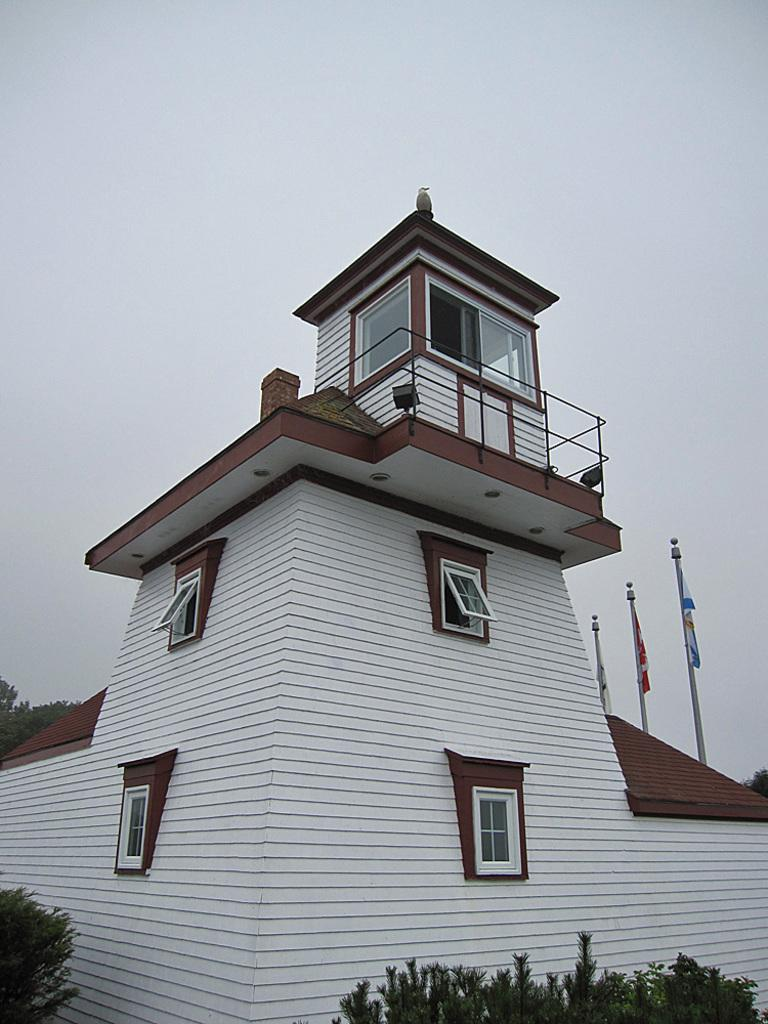What type of structure is present in the image? There is a building in the image. What features can be observed on the building? The building has windows and railings. What is located at the bottom of the image? There are plants at the bottom of the image. What can be seen attached to the building? There are flags with poles in the image. What is visible in the background of the image? The sky is visible in the background of the image. How many sisters are present in the image? There is no mention of any sisters or women in the image; it features a building with flags, plants, and a sky background. 